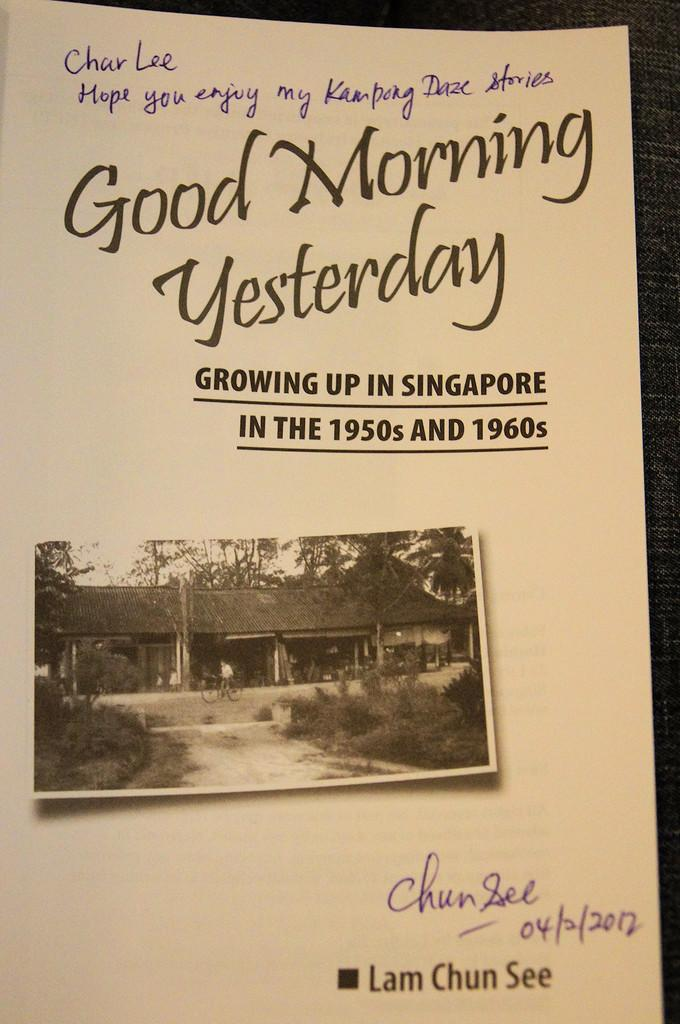<image>
Offer a succinct explanation of the picture presented. A book with stories of growing up in Singapore. 